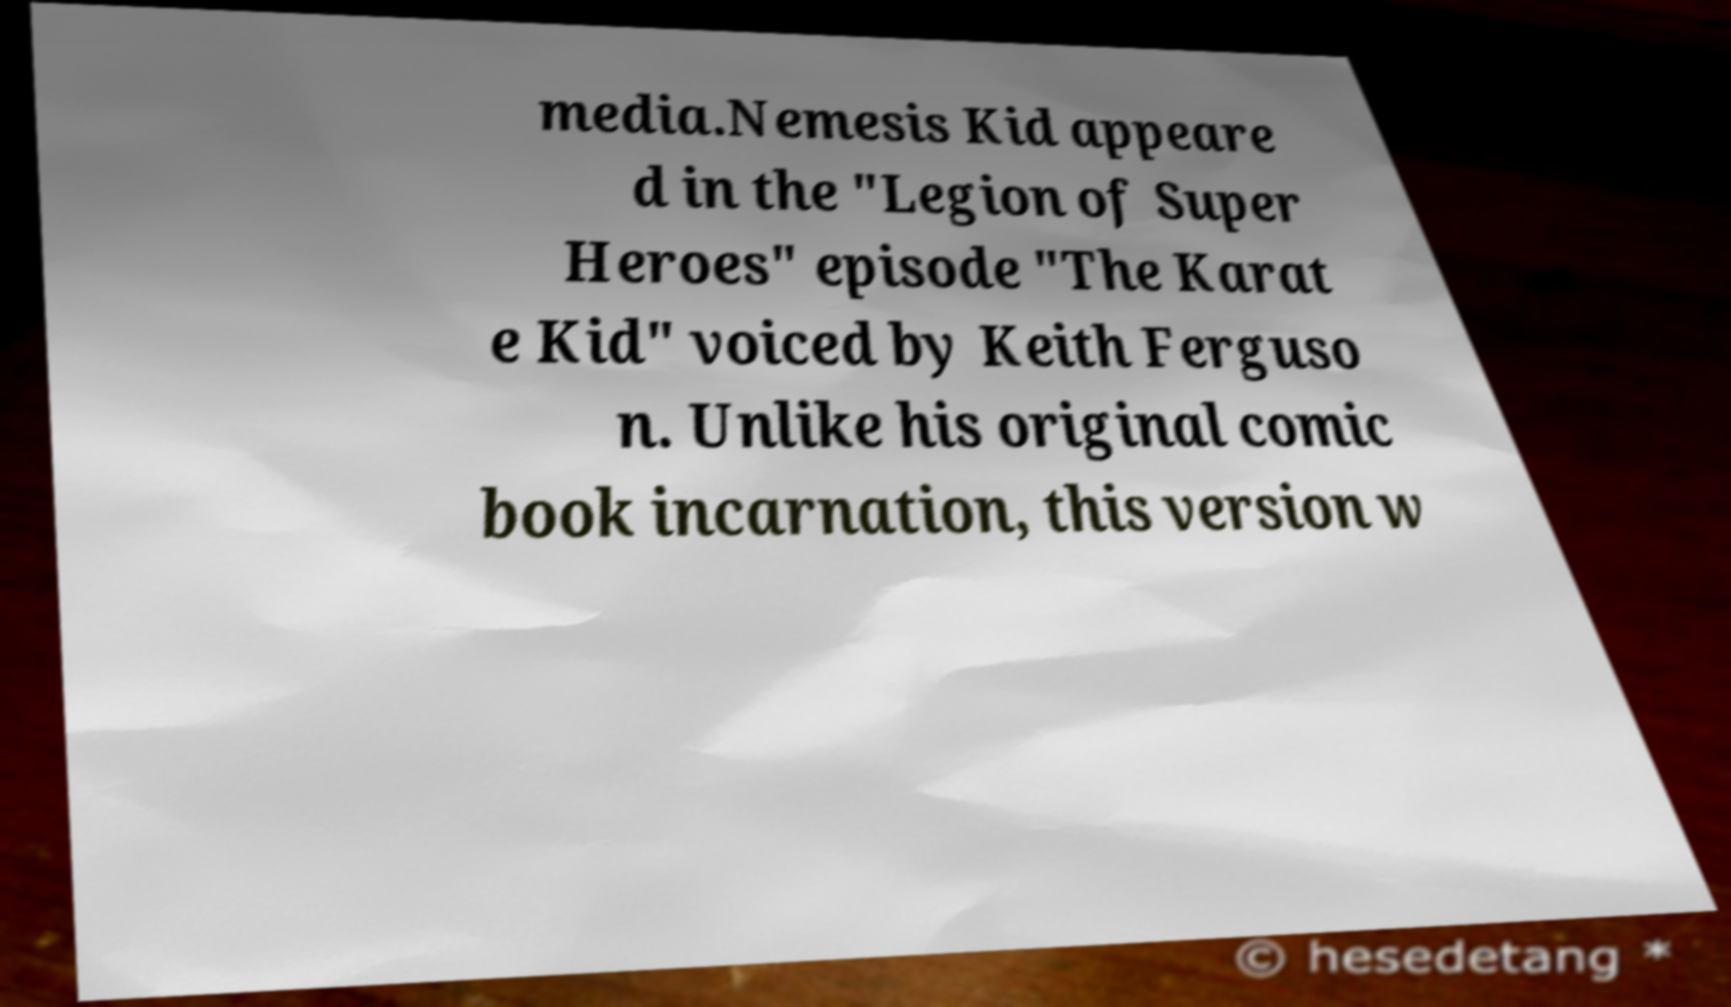Could you assist in decoding the text presented in this image and type it out clearly? media.Nemesis Kid appeare d in the "Legion of Super Heroes" episode "The Karat e Kid" voiced by Keith Ferguso n. Unlike his original comic book incarnation, this version w 